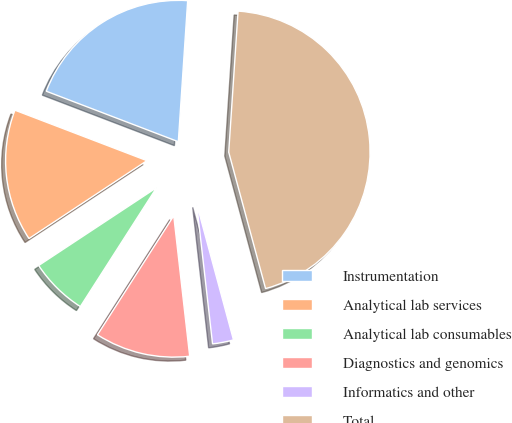Convert chart to OTSL. <chart><loc_0><loc_0><loc_500><loc_500><pie_chart><fcel>Instrumentation<fcel>Analytical lab services<fcel>Analytical lab consumables<fcel>Diagnostics and genomics<fcel>Informatics and other<fcel>Total<nl><fcel>20.24%<fcel>15.1%<fcel>6.64%<fcel>10.87%<fcel>2.4%<fcel>44.74%<nl></chart> 